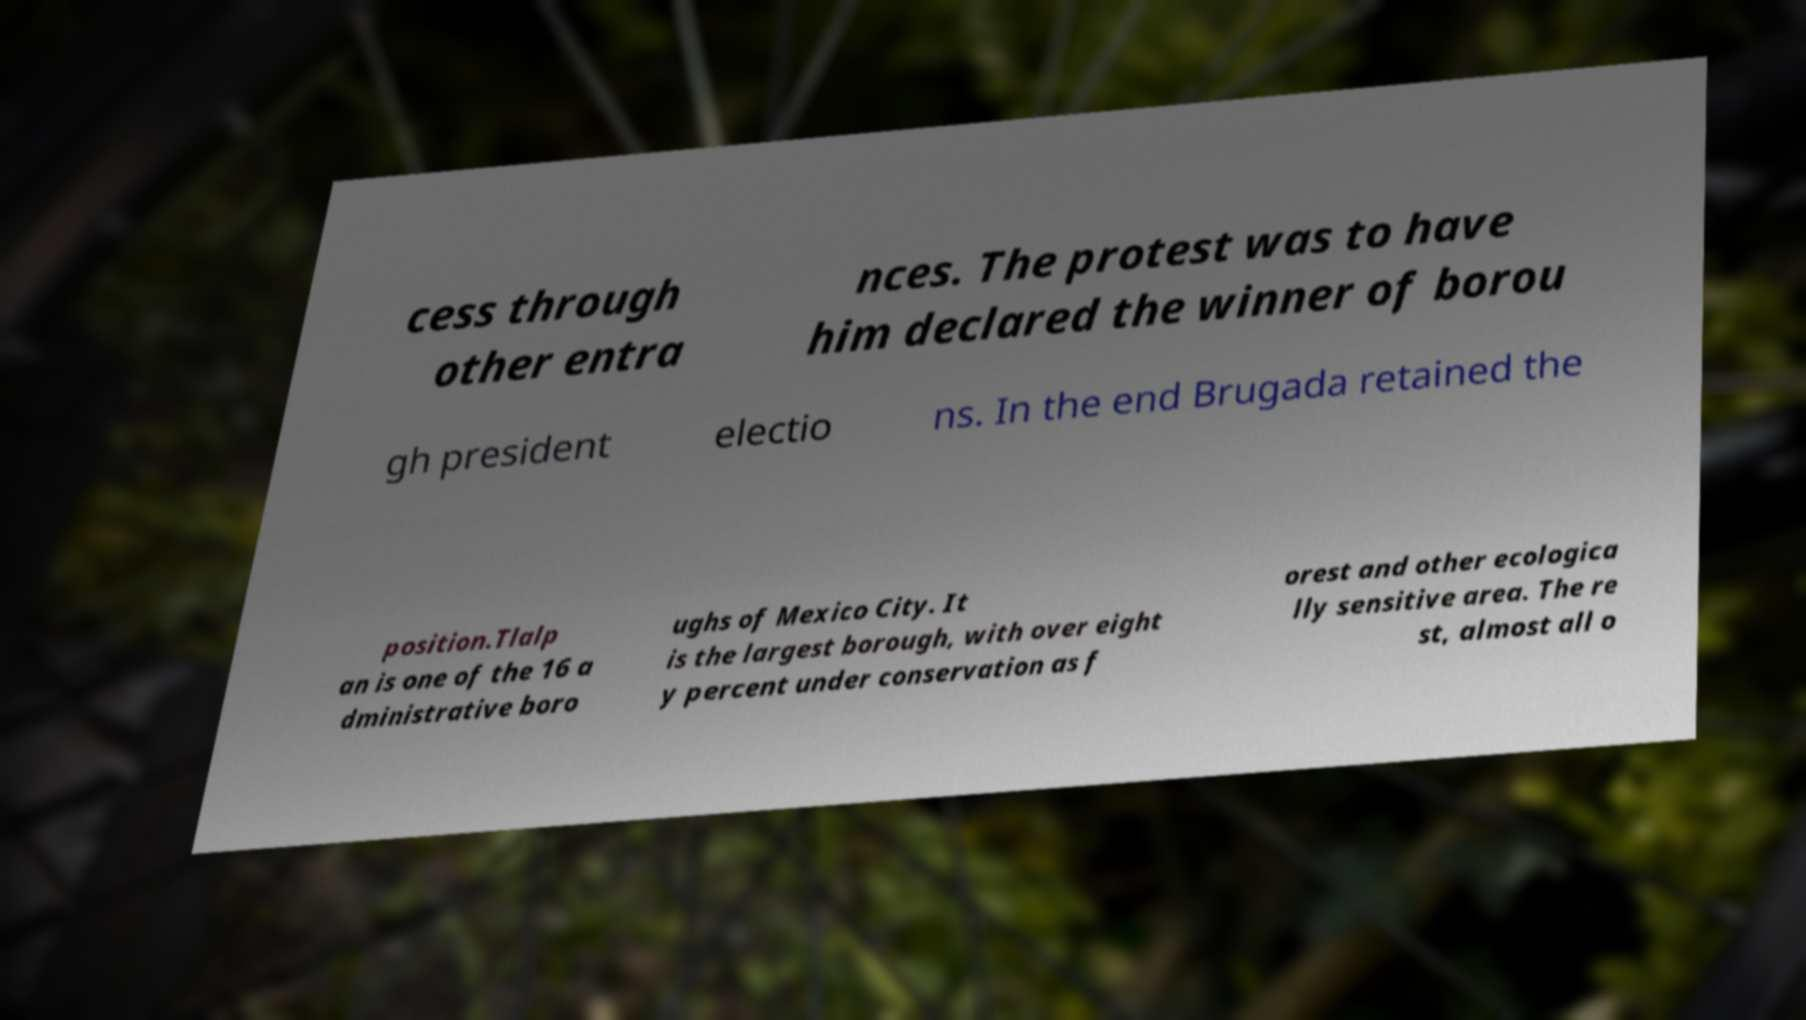What messages or text are displayed in this image? I need them in a readable, typed format. cess through other entra nces. The protest was to have him declared the winner of borou gh president electio ns. In the end Brugada retained the position.Tlalp an is one of the 16 a dministrative boro ughs of Mexico City. It is the largest borough, with over eight y percent under conservation as f orest and other ecologica lly sensitive area. The re st, almost all o 